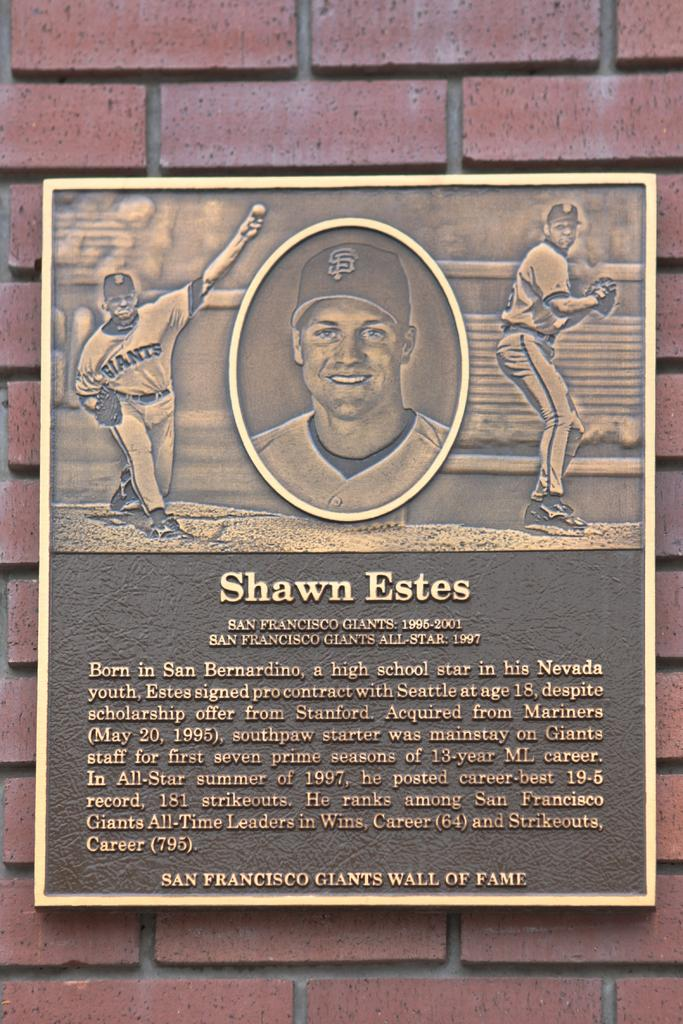<image>
Write a terse but informative summary of the picture. A shawn Estes plaque on the san francisco giants wall of fame. It has A bio of Shawn Estes and a photo of him 